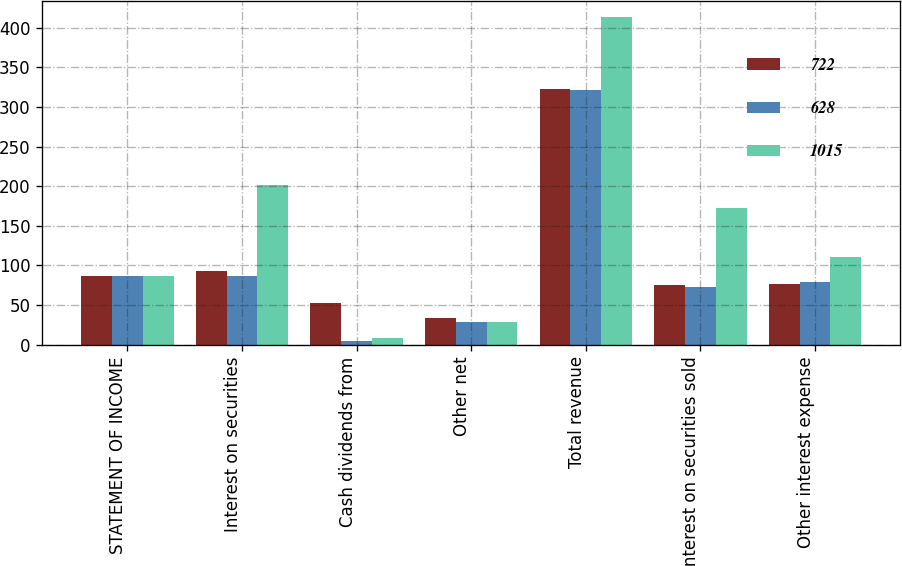<chart> <loc_0><loc_0><loc_500><loc_500><stacked_bar_chart><ecel><fcel>STATEMENT OF INCOME<fcel>Interest on securities<fcel>Cash dividends from<fcel>Other net<fcel>Total revenue<fcel>Interest on securities sold<fcel>Other interest expense<nl><fcel>722<fcel>87<fcel>93<fcel>52<fcel>33<fcel>323<fcel>75<fcel>77<nl><fcel>628<fcel>87<fcel>87<fcel>5<fcel>29<fcel>321<fcel>73<fcel>79<nl><fcel>1015<fcel>87<fcel>201<fcel>8<fcel>29<fcel>413<fcel>172<fcel>111<nl></chart> 